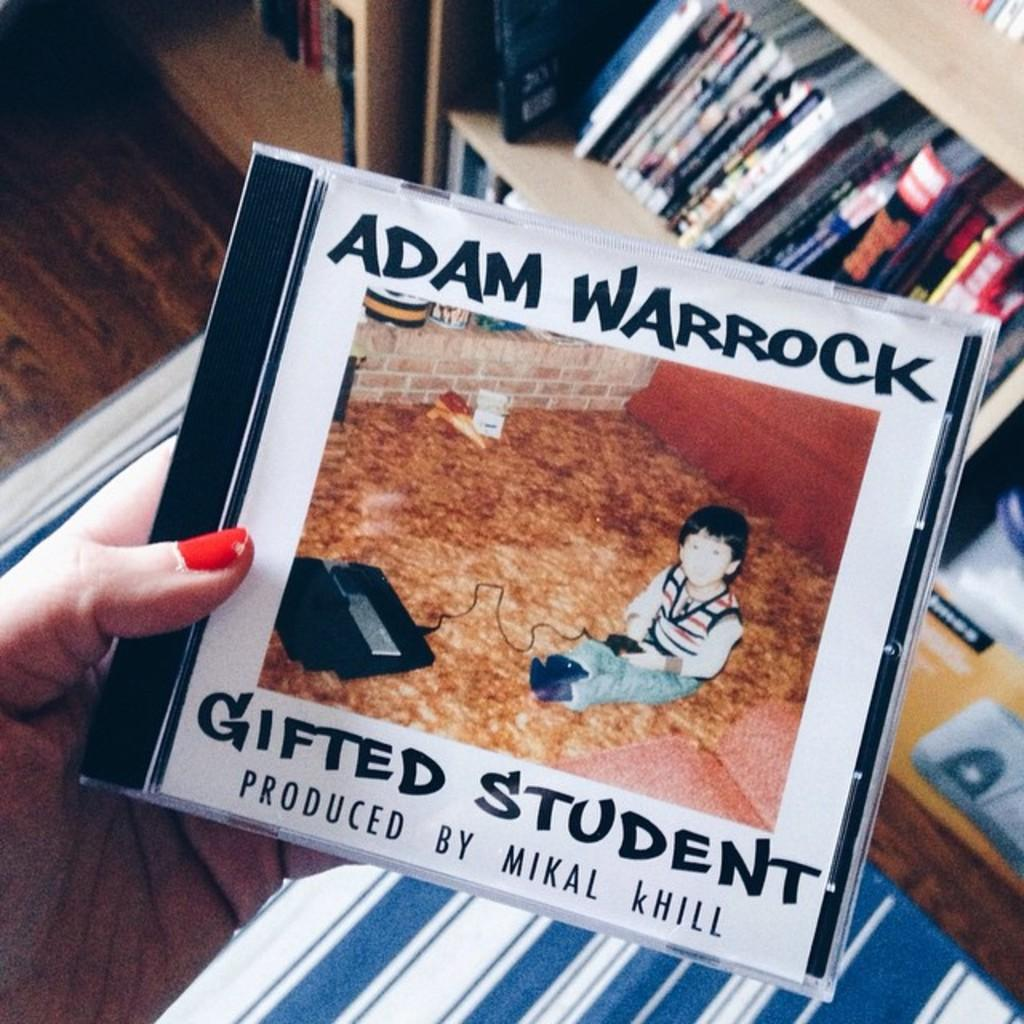Provide a one-sentence caption for the provided image. A CD  of Adam Warrock title Gifted Student produced by Mikal Khill. 